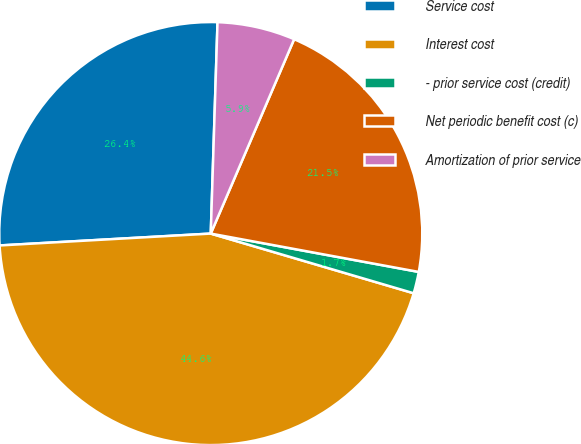Convert chart to OTSL. <chart><loc_0><loc_0><loc_500><loc_500><pie_chart><fcel>Service cost<fcel>Interest cost<fcel>- prior service cost (credit)<fcel>Net periodic benefit cost (c)<fcel>Amortization of prior service<nl><fcel>26.4%<fcel>44.55%<fcel>1.65%<fcel>21.45%<fcel>5.94%<nl></chart> 